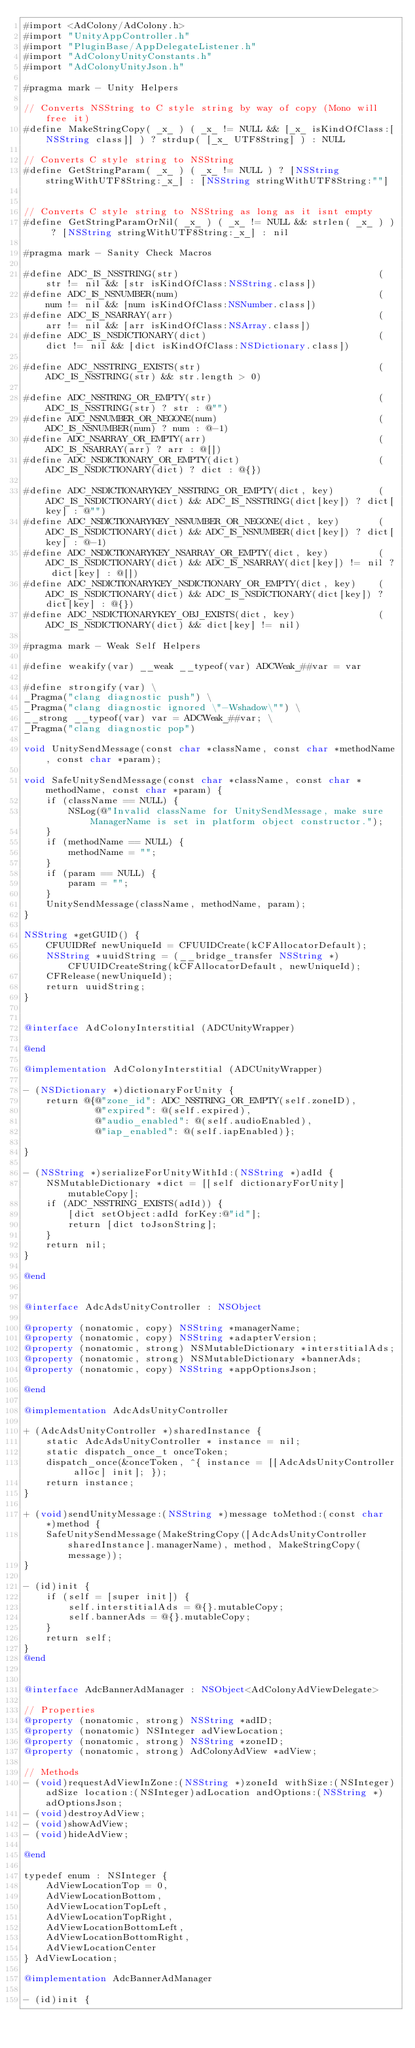<code> <loc_0><loc_0><loc_500><loc_500><_ObjectiveC_>#import <AdColony/AdColony.h>
#import "UnityAppController.h"
#import "PluginBase/AppDelegateListener.h"
#import "AdColonyUnityConstants.h"
#import "AdColonyUnityJson.h"

#pragma mark - Unity Helpers

// Converts NSString to C style string by way of copy (Mono will free it)
#define MakeStringCopy( _x_ ) ( _x_ != NULL && [_x_ isKindOfClass:[NSString class]] ) ? strdup( [_x_ UTF8String] ) : NULL

// Converts C style string to NSString
#define GetStringParam( _x_ ) ( _x_ != NULL ) ? [NSString stringWithUTF8String:_x_] : [NSString stringWithUTF8String:""]


// Converts C style string to NSString as long as it isnt empty
#define GetStringParamOrNil( _x_ ) ( _x_ != NULL && strlen( _x_ ) ) ? [NSString stringWithUTF8String:_x_] : nil

#pragma mark - Sanity Check Macros

#define ADC_IS_NSSTRING(str)                                    (str != nil && [str isKindOfClass:NSString.class])
#define ADC_IS_NSNUMBER(num)                                    (num != nil && [num isKindOfClass:NSNumber.class])
#define ADC_IS_NSARRAY(arr)                                     (arr != nil && [arr isKindOfClass:NSArray.class])
#define ADC_IS_NSDICTIONARY(dict)                               (dict != nil && [dict isKindOfClass:NSDictionary.class])

#define ADC_NSSTRING_EXISTS(str)                                (ADC_IS_NSSTRING(str) && str.length > 0)

#define ADC_NSSTRING_OR_EMPTY(str)                              (ADC_IS_NSSTRING(str) ? str : @"")
#define ADC_NSNUMBER_OR_NEGONE(num)                             (ADC_IS_NSNUMBER(num) ? num : @-1)
#define ADC_NSARRAY_OR_EMPTY(arr)                               (ADC_IS_NSARRAY(arr) ? arr : @[])
#define ADC_NSDICTIONARY_OR_EMPTY(dict)                         (ADC_IS_NSDICTIONARY(dict) ? dict : @{})

#define ADC_NSDICTIONARYKEY_NSSTRING_OR_EMPTY(dict, key)        (ADC_IS_NSDICTIONARY(dict) && ADC_IS_NSSTRING(dict[key]) ? dict[key] : @"")
#define ADC_NSDICTIONARYKEY_NSNUMBER_OR_NEGONE(dict, key)       (ADC_IS_NSDICTIONARY(dict) && ADC_IS_NSNUMBER(dict[key]) ? dict[key] : @-1)
#define ADC_NSDICTIONARYKEY_NSARRAY_OR_EMPTY(dict, key)         (ADC_IS_NSDICTIONARY(dict) && ADC_IS_NSARRAY(dict[key]) != nil ? dict[key] : @[])
#define ADC_NSDICTIONARYKEY_NSDICTIONARY_OR_EMPTY(dict, key)    (ADC_IS_NSDICTIONARY(dict) && ADC_IS_NSDICTIONARY(dict[key]) ? dict[key] : @{})
#define ADC_NSDICTIONARYKEY_OBJ_EXISTS(dict, key)               (ADC_IS_NSDICTIONARY(dict) && dict[key] != nil)

#pragma mark - Weak Self Helpers

#define weakify(var) __weak __typeof(var) ADCWeak_##var = var

#define strongify(var) \
_Pragma("clang diagnostic push") \
_Pragma("clang diagnostic ignored \"-Wshadow\"") \
__strong __typeof(var) var = ADCWeak_##var; \
_Pragma("clang diagnostic pop")

void UnitySendMessage(const char *className, const char *methodName, const char *param);

void SafeUnitySendMessage(const char *className, const char *methodName, const char *param) {
    if (className == NULL) {
        NSLog(@"Invalid className for UnitySendMessage, make sure ManagerName is set in platform object constructor.");
    }
    if (methodName == NULL) {
        methodName = "";
    }
    if (param == NULL) {
        param = "";
    }
    UnitySendMessage(className, methodName, param);
}

NSString *getGUID() {
    CFUUIDRef newUniqueId = CFUUIDCreate(kCFAllocatorDefault);
    NSString *uuidString = (__bridge_transfer NSString *)CFUUIDCreateString(kCFAllocatorDefault, newUniqueId);
    CFRelease(newUniqueId);
    return uuidString;
}


@interface AdColonyInterstitial (ADCUnityWrapper)

@end

@implementation AdColonyInterstitial (ADCUnityWrapper)

- (NSDictionary *)dictionaryForUnity {
    return @{@"zone_id": ADC_NSSTRING_OR_EMPTY(self.zoneID),
             @"expired": @(self.expired),
             @"audio_enabled": @(self.audioEnabled),
             @"iap_enabled": @(self.iapEnabled)};
    
}

- (NSString *)serializeForUnityWithId:(NSString *)adId {
    NSMutableDictionary *dict = [[self dictionaryForUnity] mutableCopy];
    if (ADC_NSSTRING_EXISTS(adId)) {
        [dict setObject:adId forKey:@"id"];
        return [dict toJsonString];
    }
    return nil;
}

@end


@interface AdcAdsUnityController : NSObject

@property (nonatomic, copy) NSString *managerName;
@property (nonatomic, copy) NSString *adapterVersion;
@property (nonatomic, strong) NSMutableDictionary *interstitialAds;
@property (nonatomic, strong) NSMutableDictionary *bannerAds;
@property (nonatomic, copy) NSString *appOptionsJson;

@end

@implementation AdcAdsUnityController

+ (AdcAdsUnityController *)sharedInstance {
    static AdcAdsUnityController * instance = nil;
    static dispatch_once_t onceToken;
    dispatch_once(&onceToken, ^{ instance = [[AdcAdsUnityController alloc] init]; });
    return instance;
}

+ (void)sendUnityMessage:(NSString *)message toMethod:(const char *)method {
    SafeUnitySendMessage(MakeStringCopy([AdcAdsUnityController sharedInstance].managerName), method, MakeStringCopy(message));
}

- (id)init {
    if (self = [super init]) {
        self.interstitialAds = @{}.mutableCopy;
        self.bannerAds = @{}.mutableCopy;
    }
    return self;
}
@end


@interface AdcBannerAdManager : NSObject<AdColonyAdViewDelegate>

// Properties
@property (nonatomic, strong) NSString *adID;
@property (nonatomic) NSInteger adViewLocation;
@property (nonatomic, strong) NSString *zoneID;
@property (nonatomic, strong) AdColonyAdView *adView;

// Methods
- (void)requestAdViewInZone:(NSString *)zoneId withSize:(NSInteger)adSize location:(NSInteger)adLocation andOptions:(NSString *)adOptionsJson;
- (void)destroyAdView;
- (void)showAdView;
- (void)hideAdView;

@end

typedef enum : NSInteger {
    AdViewLocationTop = 0,
    AdViewLocationBottom,
    AdViewLocationTopLeft,
    AdViewLocationTopRight,
    AdViewLocationBottomLeft,
    AdViewLocationBottomRight,
    AdViewLocationCenter
} AdViewLocation;

@implementation AdcBannerAdManager

- (id)init {</code> 